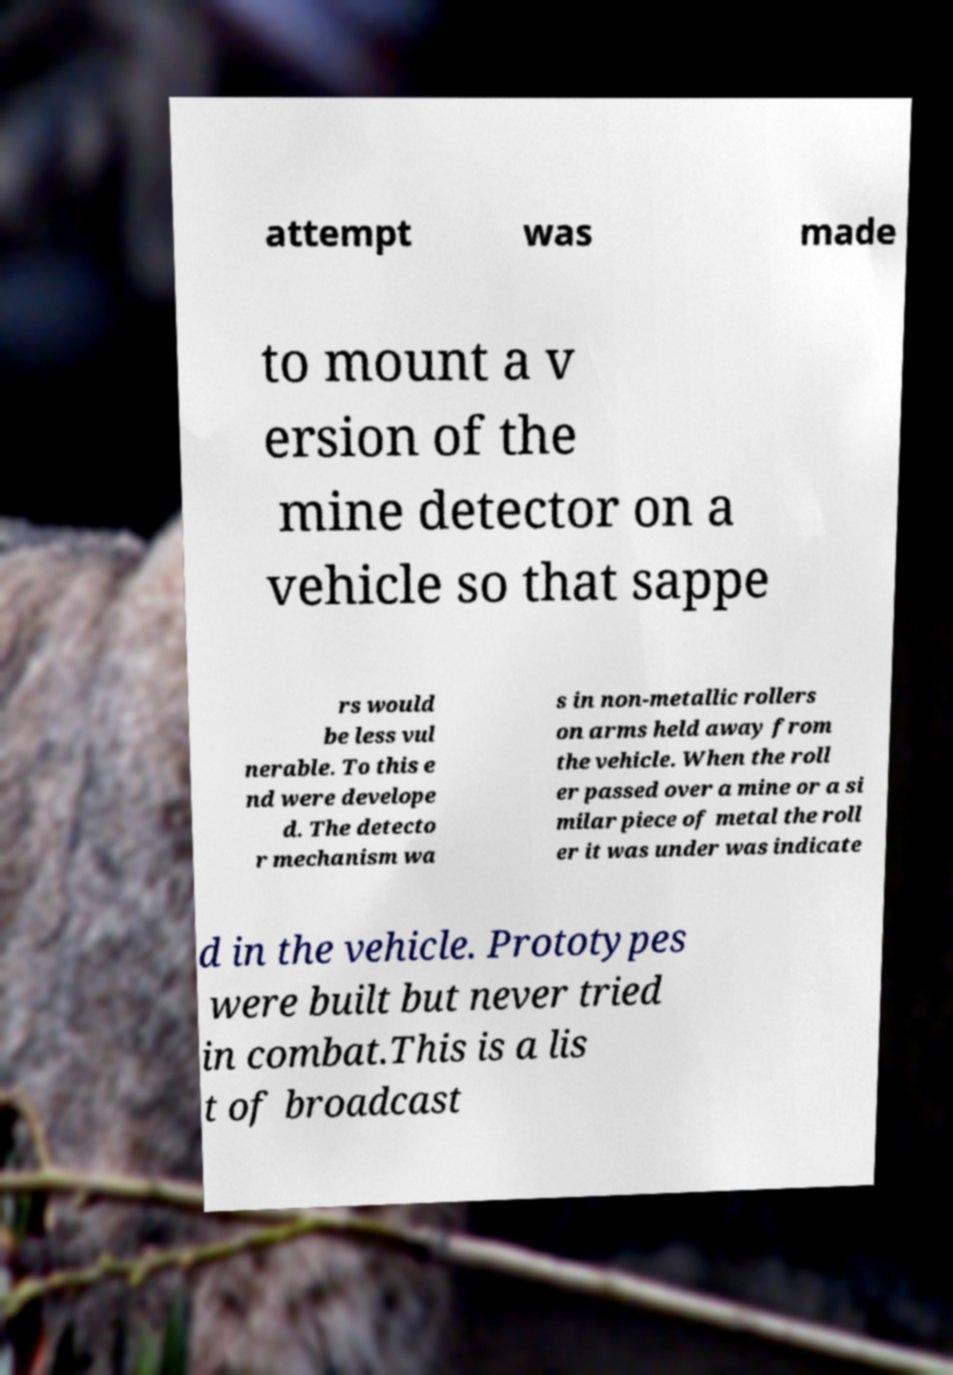Could you assist in decoding the text presented in this image and type it out clearly? attempt was made to mount a v ersion of the mine detector on a vehicle so that sappe rs would be less vul nerable. To this e nd were develope d. The detecto r mechanism wa s in non-metallic rollers on arms held away from the vehicle. When the roll er passed over a mine or a si milar piece of metal the roll er it was under was indicate d in the vehicle. Prototypes were built but never tried in combat.This is a lis t of broadcast 